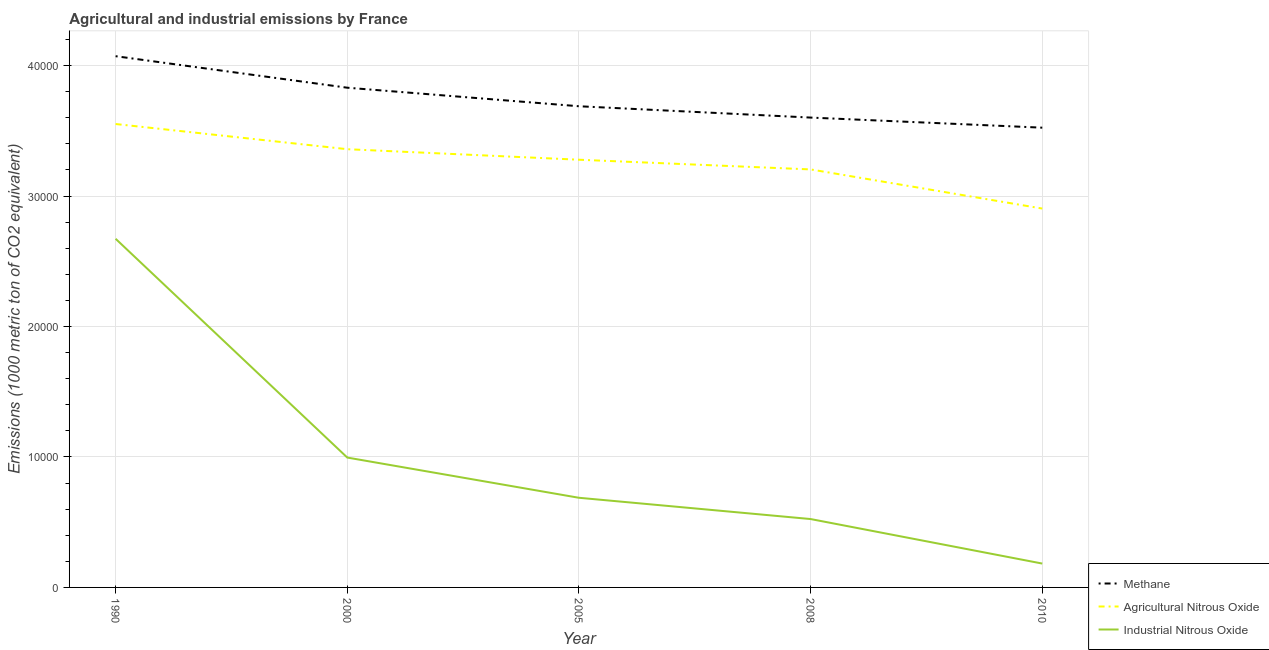What is the amount of industrial nitrous oxide emissions in 1990?
Ensure brevity in your answer.  2.67e+04. Across all years, what is the maximum amount of agricultural nitrous oxide emissions?
Provide a short and direct response. 3.55e+04. Across all years, what is the minimum amount of industrial nitrous oxide emissions?
Your answer should be very brief. 1828.8. What is the total amount of industrial nitrous oxide emissions in the graph?
Provide a succinct answer. 5.06e+04. What is the difference between the amount of methane emissions in 2000 and that in 2005?
Offer a very short reply. 1421.2. What is the difference between the amount of methane emissions in 1990 and the amount of industrial nitrous oxide emissions in 2005?
Your answer should be compact. 3.38e+04. What is the average amount of methane emissions per year?
Offer a very short reply. 3.74e+04. In the year 2008, what is the difference between the amount of methane emissions and amount of industrial nitrous oxide emissions?
Offer a very short reply. 3.08e+04. What is the ratio of the amount of agricultural nitrous oxide emissions in 2005 to that in 2008?
Give a very brief answer. 1.02. What is the difference between the highest and the second highest amount of methane emissions?
Provide a succinct answer. 2415.3. What is the difference between the highest and the lowest amount of methane emissions?
Offer a very short reply. 5479. Is it the case that in every year, the sum of the amount of methane emissions and amount of agricultural nitrous oxide emissions is greater than the amount of industrial nitrous oxide emissions?
Keep it short and to the point. Yes. Does the amount of methane emissions monotonically increase over the years?
Provide a succinct answer. No. Is the amount of agricultural nitrous oxide emissions strictly less than the amount of industrial nitrous oxide emissions over the years?
Keep it short and to the point. No. What is the difference between two consecutive major ticks on the Y-axis?
Your answer should be compact. 10000. Does the graph contain grids?
Your answer should be very brief. Yes. How many legend labels are there?
Ensure brevity in your answer.  3. How are the legend labels stacked?
Your answer should be compact. Vertical. What is the title of the graph?
Offer a very short reply. Agricultural and industrial emissions by France. Does "Social Protection and Labor" appear as one of the legend labels in the graph?
Make the answer very short. No. What is the label or title of the Y-axis?
Make the answer very short. Emissions (1000 metric ton of CO2 equivalent). What is the Emissions (1000 metric ton of CO2 equivalent) of Methane in 1990?
Your answer should be very brief. 4.07e+04. What is the Emissions (1000 metric ton of CO2 equivalent) of Agricultural Nitrous Oxide in 1990?
Keep it short and to the point. 3.55e+04. What is the Emissions (1000 metric ton of CO2 equivalent) of Industrial Nitrous Oxide in 1990?
Your answer should be compact. 2.67e+04. What is the Emissions (1000 metric ton of CO2 equivalent) of Methane in 2000?
Offer a very short reply. 3.83e+04. What is the Emissions (1000 metric ton of CO2 equivalent) in Agricultural Nitrous Oxide in 2000?
Ensure brevity in your answer.  3.36e+04. What is the Emissions (1000 metric ton of CO2 equivalent) in Industrial Nitrous Oxide in 2000?
Offer a very short reply. 9953.8. What is the Emissions (1000 metric ton of CO2 equivalent) of Methane in 2005?
Provide a short and direct response. 3.69e+04. What is the Emissions (1000 metric ton of CO2 equivalent) in Agricultural Nitrous Oxide in 2005?
Your answer should be compact. 3.28e+04. What is the Emissions (1000 metric ton of CO2 equivalent) in Industrial Nitrous Oxide in 2005?
Make the answer very short. 6871.6. What is the Emissions (1000 metric ton of CO2 equivalent) of Methane in 2008?
Your response must be concise. 3.60e+04. What is the Emissions (1000 metric ton of CO2 equivalent) of Agricultural Nitrous Oxide in 2008?
Your response must be concise. 3.20e+04. What is the Emissions (1000 metric ton of CO2 equivalent) in Industrial Nitrous Oxide in 2008?
Your answer should be compact. 5241.3. What is the Emissions (1000 metric ton of CO2 equivalent) of Methane in 2010?
Provide a succinct answer. 3.52e+04. What is the Emissions (1000 metric ton of CO2 equivalent) in Agricultural Nitrous Oxide in 2010?
Offer a very short reply. 2.90e+04. What is the Emissions (1000 metric ton of CO2 equivalent) in Industrial Nitrous Oxide in 2010?
Your answer should be very brief. 1828.8. Across all years, what is the maximum Emissions (1000 metric ton of CO2 equivalent) in Methane?
Your response must be concise. 4.07e+04. Across all years, what is the maximum Emissions (1000 metric ton of CO2 equivalent) of Agricultural Nitrous Oxide?
Give a very brief answer. 3.55e+04. Across all years, what is the maximum Emissions (1000 metric ton of CO2 equivalent) of Industrial Nitrous Oxide?
Offer a very short reply. 2.67e+04. Across all years, what is the minimum Emissions (1000 metric ton of CO2 equivalent) in Methane?
Your answer should be very brief. 3.52e+04. Across all years, what is the minimum Emissions (1000 metric ton of CO2 equivalent) in Agricultural Nitrous Oxide?
Provide a succinct answer. 2.90e+04. Across all years, what is the minimum Emissions (1000 metric ton of CO2 equivalent) in Industrial Nitrous Oxide?
Make the answer very short. 1828.8. What is the total Emissions (1000 metric ton of CO2 equivalent) of Methane in the graph?
Make the answer very short. 1.87e+05. What is the total Emissions (1000 metric ton of CO2 equivalent) in Agricultural Nitrous Oxide in the graph?
Ensure brevity in your answer.  1.63e+05. What is the total Emissions (1000 metric ton of CO2 equivalent) in Industrial Nitrous Oxide in the graph?
Your answer should be very brief. 5.06e+04. What is the difference between the Emissions (1000 metric ton of CO2 equivalent) in Methane in 1990 and that in 2000?
Offer a terse response. 2415.3. What is the difference between the Emissions (1000 metric ton of CO2 equivalent) in Agricultural Nitrous Oxide in 1990 and that in 2000?
Ensure brevity in your answer.  1930.3. What is the difference between the Emissions (1000 metric ton of CO2 equivalent) of Industrial Nitrous Oxide in 1990 and that in 2000?
Your response must be concise. 1.68e+04. What is the difference between the Emissions (1000 metric ton of CO2 equivalent) of Methane in 1990 and that in 2005?
Keep it short and to the point. 3836.5. What is the difference between the Emissions (1000 metric ton of CO2 equivalent) of Agricultural Nitrous Oxide in 1990 and that in 2005?
Give a very brief answer. 2736.8. What is the difference between the Emissions (1000 metric ton of CO2 equivalent) of Industrial Nitrous Oxide in 1990 and that in 2005?
Make the answer very short. 1.99e+04. What is the difference between the Emissions (1000 metric ton of CO2 equivalent) in Methane in 1990 and that in 2008?
Offer a terse response. 4704.7. What is the difference between the Emissions (1000 metric ton of CO2 equivalent) of Agricultural Nitrous Oxide in 1990 and that in 2008?
Provide a succinct answer. 3480.3. What is the difference between the Emissions (1000 metric ton of CO2 equivalent) of Industrial Nitrous Oxide in 1990 and that in 2008?
Provide a short and direct response. 2.15e+04. What is the difference between the Emissions (1000 metric ton of CO2 equivalent) of Methane in 1990 and that in 2010?
Your response must be concise. 5479. What is the difference between the Emissions (1000 metric ton of CO2 equivalent) in Agricultural Nitrous Oxide in 1990 and that in 2010?
Offer a terse response. 6479.5. What is the difference between the Emissions (1000 metric ton of CO2 equivalent) in Industrial Nitrous Oxide in 1990 and that in 2010?
Offer a very short reply. 2.49e+04. What is the difference between the Emissions (1000 metric ton of CO2 equivalent) in Methane in 2000 and that in 2005?
Provide a succinct answer. 1421.2. What is the difference between the Emissions (1000 metric ton of CO2 equivalent) in Agricultural Nitrous Oxide in 2000 and that in 2005?
Your answer should be compact. 806.5. What is the difference between the Emissions (1000 metric ton of CO2 equivalent) of Industrial Nitrous Oxide in 2000 and that in 2005?
Make the answer very short. 3082.2. What is the difference between the Emissions (1000 metric ton of CO2 equivalent) of Methane in 2000 and that in 2008?
Your response must be concise. 2289.4. What is the difference between the Emissions (1000 metric ton of CO2 equivalent) of Agricultural Nitrous Oxide in 2000 and that in 2008?
Ensure brevity in your answer.  1550. What is the difference between the Emissions (1000 metric ton of CO2 equivalent) of Industrial Nitrous Oxide in 2000 and that in 2008?
Make the answer very short. 4712.5. What is the difference between the Emissions (1000 metric ton of CO2 equivalent) in Methane in 2000 and that in 2010?
Provide a short and direct response. 3063.7. What is the difference between the Emissions (1000 metric ton of CO2 equivalent) of Agricultural Nitrous Oxide in 2000 and that in 2010?
Offer a very short reply. 4549.2. What is the difference between the Emissions (1000 metric ton of CO2 equivalent) in Industrial Nitrous Oxide in 2000 and that in 2010?
Your response must be concise. 8125. What is the difference between the Emissions (1000 metric ton of CO2 equivalent) of Methane in 2005 and that in 2008?
Make the answer very short. 868.2. What is the difference between the Emissions (1000 metric ton of CO2 equivalent) in Agricultural Nitrous Oxide in 2005 and that in 2008?
Your answer should be very brief. 743.5. What is the difference between the Emissions (1000 metric ton of CO2 equivalent) of Industrial Nitrous Oxide in 2005 and that in 2008?
Make the answer very short. 1630.3. What is the difference between the Emissions (1000 metric ton of CO2 equivalent) in Methane in 2005 and that in 2010?
Offer a terse response. 1642.5. What is the difference between the Emissions (1000 metric ton of CO2 equivalent) of Agricultural Nitrous Oxide in 2005 and that in 2010?
Make the answer very short. 3742.7. What is the difference between the Emissions (1000 metric ton of CO2 equivalent) of Industrial Nitrous Oxide in 2005 and that in 2010?
Give a very brief answer. 5042.8. What is the difference between the Emissions (1000 metric ton of CO2 equivalent) of Methane in 2008 and that in 2010?
Offer a very short reply. 774.3. What is the difference between the Emissions (1000 metric ton of CO2 equivalent) of Agricultural Nitrous Oxide in 2008 and that in 2010?
Your response must be concise. 2999.2. What is the difference between the Emissions (1000 metric ton of CO2 equivalent) of Industrial Nitrous Oxide in 2008 and that in 2010?
Provide a succinct answer. 3412.5. What is the difference between the Emissions (1000 metric ton of CO2 equivalent) of Methane in 1990 and the Emissions (1000 metric ton of CO2 equivalent) of Agricultural Nitrous Oxide in 2000?
Your answer should be very brief. 7128.7. What is the difference between the Emissions (1000 metric ton of CO2 equivalent) in Methane in 1990 and the Emissions (1000 metric ton of CO2 equivalent) in Industrial Nitrous Oxide in 2000?
Make the answer very short. 3.08e+04. What is the difference between the Emissions (1000 metric ton of CO2 equivalent) in Agricultural Nitrous Oxide in 1990 and the Emissions (1000 metric ton of CO2 equivalent) in Industrial Nitrous Oxide in 2000?
Your answer should be compact. 2.56e+04. What is the difference between the Emissions (1000 metric ton of CO2 equivalent) of Methane in 1990 and the Emissions (1000 metric ton of CO2 equivalent) of Agricultural Nitrous Oxide in 2005?
Keep it short and to the point. 7935.2. What is the difference between the Emissions (1000 metric ton of CO2 equivalent) of Methane in 1990 and the Emissions (1000 metric ton of CO2 equivalent) of Industrial Nitrous Oxide in 2005?
Ensure brevity in your answer.  3.38e+04. What is the difference between the Emissions (1000 metric ton of CO2 equivalent) of Agricultural Nitrous Oxide in 1990 and the Emissions (1000 metric ton of CO2 equivalent) of Industrial Nitrous Oxide in 2005?
Offer a terse response. 2.86e+04. What is the difference between the Emissions (1000 metric ton of CO2 equivalent) of Methane in 1990 and the Emissions (1000 metric ton of CO2 equivalent) of Agricultural Nitrous Oxide in 2008?
Your response must be concise. 8678.7. What is the difference between the Emissions (1000 metric ton of CO2 equivalent) of Methane in 1990 and the Emissions (1000 metric ton of CO2 equivalent) of Industrial Nitrous Oxide in 2008?
Give a very brief answer. 3.55e+04. What is the difference between the Emissions (1000 metric ton of CO2 equivalent) of Agricultural Nitrous Oxide in 1990 and the Emissions (1000 metric ton of CO2 equivalent) of Industrial Nitrous Oxide in 2008?
Your response must be concise. 3.03e+04. What is the difference between the Emissions (1000 metric ton of CO2 equivalent) of Methane in 1990 and the Emissions (1000 metric ton of CO2 equivalent) of Agricultural Nitrous Oxide in 2010?
Your response must be concise. 1.17e+04. What is the difference between the Emissions (1000 metric ton of CO2 equivalent) of Methane in 1990 and the Emissions (1000 metric ton of CO2 equivalent) of Industrial Nitrous Oxide in 2010?
Ensure brevity in your answer.  3.89e+04. What is the difference between the Emissions (1000 metric ton of CO2 equivalent) in Agricultural Nitrous Oxide in 1990 and the Emissions (1000 metric ton of CO2 equivalent) in Industrial Nitrous Oxide in 2010?
Make the answer very short. 3.37e+04. What is the difference between the Emissions (1000 metric ton of CO2 equivalent) of Methane in 2000 and the Emissions (1000 metric ton of CO2 equivalent) of Agricultural Nitrous Oxide in 2005?
Keep it short and to the point. 5519.9. What is the difference between the Emissions (1000 metric ton of CO2 equivalent) of Methane in 2000 and the Emissions (1000 metric ton of CO2 equivalent) of Industrial Nitrous Oxide in 2005?
Keep it short and to the point. 3.14e+04. What is the difference between the Emissions (1000 metric ton of CO2 equivalent) of Agricultural Nitrous Oxide in 2000 and the Emissions (1000 metric ton of CO2 equivalent) of Industrial Nitrous Oxide in 2005?
Your answer should be very brief. 2.67e+04. What is the difference between the Emissions (1000 metric ton of CO2 equivalent) in Methane in 2000 and the Emissions (1000 metric ton of CO2 equivalent) in Agricultural Nitrous Oxide in 2008?
Provide a succinct answer. 6263.4. What is the difference between the Emissions (1000 metric ton of CO2 equivalent) of Methane in 2000 and the Emissions (1000 metric ton of CO2 equivalent) of Industrial Nitrous Oxide in 2008?
Provide a succinct answer. 3.31e+04. What is the difference between the Emissions (1000 metric ton of CO2 equivalent) in Agricultural Nitrous Oxide in 2000 and the Emissions (1000 metric ton of CO2 equivalent) in Industrial Nitrous Oxide in 2008?
Your response must be concise. 2.83e+04. What is the difference between the Emissions (1000 metric ton of CO2 equivalent) of Methane in 2000 and the Emissions (1000 metric ton of CO2 equivalent) of Agricultural Nitrous Oxide in 2010?
Offer a terse response. 9262.6. What is the difference between the Emissions (1000 metric ton of CO2 equivalent) in Methane in 2000 and the Emissions (1000 metric ton of CO2 equivalent) in Industrial Nitrous Oxide in 2010?
Keep it short and to the point. 3.65e+04. What is the difference between the Emissions (1000 metric ton of CO2 equivalent) of Agricultural Nitrous Oxide in 2000 and the Emissions (1000 metric ton of CO2 equivalent) of Industrial Nitrous Oxide in 2010?
Offer a terse response. 3.18e+04. What is the difference between the Emissions (1000 metric ton of CO2 equivalent) in Methane in 2005 and the Emissions (1000 metric ton of CO2 equivalent) in Agricultural Nitrous Oxide in 2008?
Offer a very short reply. 4842.2. What is the difference between the Emissions (1000 metric ton of CO2 equivalent) in Methane in 2005 and the Emissions (1000 metric ton of CO2 equivalent) in Industrial Nitrous Oxide in 2008?
Give a very brief answer. 3.16e+04. What is the difference between the Emissions (1000 metric ton of CO2 equivalent) of Agricultural Nitrous Oxide in 2005 and the Emissions (1000 metric ton of CO2 equivalent) of Industrial Nitrous Oxide in 2008?
Keep it short and to the point. 2.75e+04. What is the difference between the Emissions (1000 metric ton of CO2 equivalent) of Methane in 2005 and the Emissions (1000 metric ton of CO2 equivalent) of Agricultural Nitrous Oxide in 2010?
Provide a succinct answer. 7841.4. What is the difference between the Emissions (1000 metric ton of CO2 equivalent) of Methane in 2005 and the Emissions (1000 metric ton of CO2 equivalent) of Industrial Nitrous Oxide in 2010?
Your answer should be compact. 3.51e+04. What is the difference between the Emissions (1000 metric ton of CO2 equivalent) in Agricultural Nitrous Oxide in 2005 and the Emissions (1000 metric ton of CO2 equivalent) in Industrial Nitrous Oxide in 2010?
Offer a terse response. 3.10e+04. What is the difference between the Emissions (1000 metric ton of CO2 equivalent) of Methane in 2008 and the Emissions (1000 metric ton of CO2 equivalent) of Agricultural Nitrous Oxide in 2010?
Give a very brief answer. 6973.2. What is the difference between the Emissions (1000 metric ton of CO2 equivalent) in Methane in 2008 and the Emissions (1000 metric ton of CO2 equivalent) in Industrial Nitrous Oxide in 2010?
Offer a terse response. 3.42e+04. What is the difference between the Emissions (1000 metric ton of CO2 equivalent) in Agricultural Nitrous Oxide in 2008 and the Emissions (1000 metric ton of CO2 equivalent) in Industrial Nitrous Oxide in 2010?
Keep it short and to the point. 3.02e+04. What is the average Emissions (1000 metric ton of CO2 equivalent) of Methane per year?
Provide a succinct answer. 3.74e+04. What is the average Emissions (1000 metric ton of CO2 equivalent) in Agricultural Nitrous Oxide per year?
Your response must be concise. 3.26e+04. What is the average Emissions (1000 metric ton of CO2 equivalent) of Industrial Nitrous Oxide per year?
Make the answer very short. 1.01e+04. In the year 1990, what is the difference between the Emissions (1000 metric ton of CO2 equivalent) of Methane and Emissions (1000 metric ton of CO2 equivalent) of Agricultural Nitrous Oxide?
Your answer should be compact. 5198.4. In the year 1990, what is the difference between the Emissions (1000 metric ton of CO2 equivalent) of Methane and Emissions (1000 metric ton of CO2 equivalent) of Industrial Nitrous Oxide?
Keep it short and to the point. 1.40e+04. In the year 1990, what is the difference between the Emissions (1000 metric ton of CO2 equivalent) of Agricultural Nitrous Oxide and Emissions (1000 metric ton of CO2 equivalent) of Industrial Nitrous Oxide?
Your answer should be compact. 8797.6. In the year 2000, what is the difference between the Emissions (1000 metric ton of CO2 equivalent) of Methane and Emissions (1000 metric ton of CO2 equivalent) of Agricultural Nitrous Oxide?
Your response must be concise. 4713.4. In the year 2000, what is the difference between the Emissions (1000 metric ton of CO2 equivalent) of Methane and Emissions (1000 metric ton of CO2 equivalent) of Industrial Nitrous Oxide?
Offer a very short reply. 2.83e+04. In the year 2000, what is the difference between the Emissions (1000 metric ton of CO2 equivalent) in Agricultural Nitrous Oxide and Emissions (1000 metric ton of CO2 equivalent) in Industrial Nitrous Oxide?
Provide a short and direct response. 2.36e+04. In the year 2005, what is the difference between the Emissions (1000 metric ton of CO2 equivalent) of Methane and Emissions (1000 metric ton of CO2 equivalent) of Agricultural Nitrous Oxide?
Your answer should be compact. 4098.7. In the year 2005, what is the difference between the Emissions (1000 metric ton of CO2 equivalent) of Methane and Emissions (1000 metric ton of CO2 equivalent) of Industrial Nitrous Oxide?
Ensure brevity in your answer.  3.00e+04. In the year 2005, what is the difference between the Emissions (1000 metric ton of CO2 equivalent) in Agricultural Nitrous Oxide and Emissions (1000 metric ton of CO2 equivalent) in Industrial Nitrous Oxide?
Keep it short and to the point. 2.59e+04. In the year 2008, what is the difference between the Emissions (1000 metric ton of CO2 equivalent) of Methane and Emissions (1000 metric ton of CO2 equivalent) of Agricultural Nitrous Oxide?
Provide a succinct answer. 3974. In the year 2008, what is the difference between the Emissions (1000 metric ton of CO2 equivalent) in Methane and Emissions (1000 metric ton of CO2 equivalent) in Industrial Nitrous Oxide?
Provide a short and direct response. 3.08e+04. In the year 2008, what is the difference between the Emissions (1000 metric ton of CO2 equivalent) of Agricultural Nitrous Oxide and Emissions (1000 metric ton of CO2 equivalent) of Industrial Nitrous Oxide?
Provide a short and direct response. 2.68e+04. In the year 2010, what is the difference between the Emissions (1000 metric ton of CO2 equivalent) in Methane and Emissions (1000 metric ton of CO2 equivalent) in Agricultural Nitrous Oxide?
Offer a very short reply. 6198.9. In the year 2010, what is the difference between the Emissions (1000 metric ton of CO2 equivalent) in Methane and Emissions (1000 metric ton of CO2 equivalent) in Industrial Nitrous Oxide?
Your answer should be compact. 3.34e+04. In the year 2010, what is the difference between the Emissions (1000 metric ton of CO2 equivalent) in Agricultural Nitrous Oxide and Emissions (1000 metric ton of CO2 equivalent) in Industrial Nitrous Oxide?
Ensure brevity in your answer.  2.72e+04. What is the ratio of the Emissions (1000 metric ton of CO2 equivalent) of Methane in 1990 to that in 2000?
Provide a succinct answer. 1.06. What is the ratio of the Emissions (1000 metric ton of CO2 equivalent) of Agricultural Nitrous Oxide in 1990 to that in 2000?
Your response must be concise. 1.06. What is the ratio of the Emissions (1000 metric ton of CO2 equivalent) of Industrial Nitrous Oxide in 1990 to that in 2000?
Offer a terse response. 2.68. What is the ratio of the Emissions (1000 metric ton of CO2 equivalent) of Methane in 1990 to that in 2005?
Offer a very short reply. 1.1. What is the ratio of the Emissions (1000 metric ton of CO2 equivalent) in Agricultural Nitrous Oxide in 1990 to that in 2005?
Give a very brief answer. 1.08. What is the ratio of the Emissions (1000 metric ton of CO2 equivalent) of Industrial Nitrous Oxide in 1990 to that in 2005?
Provide a succinct answer. 3.89. What is the ratio of the Emissions (1000 metric ton of CO2 equivalent) in Methane in 1990 to that in 2008?
Offer a terse response. 1.13. What is the ratio of the Emissions (1000 metric ton of CO2 equivalent) of Agricultural Nitrous Oxide in 1990 to that in 2008?
Provide a short and direct response. 1.11. What is the ratio of the Emissions (1000 metric ton of CO2 equivalent) of Industrial Nitrous Oxide in 1990 to that in 2008?
Your answer should be compact. 5.1. What is the ratio of the Emissions (1000 metric ton of CO2 equivalent) of Methane in 1990 to that in 2010?
Your answer should be compact. 1.16. What is the ratio of the Emissions (1000 metric ton of CO2 equivalent) of Agricultural Nitrous Oxide in 1990 to that in 2010?
Keep it short and to the point. 1.22. What is the ratio of the Emissions (1000 metric ton of CO2 equivalent) of Industrial Nitrous Oxide in 1990 to that in 2010?
Keep it short and to the point. 14.61. What is the ratio of the Emissions (1000 metric ton of CO2 equivalent) of Methane in 2000 to that in 2005?
Your answer should be compact. 1.04. What is the ratio of the Emissions (1000 metric ton of CO2 equivalent) in Agricultural Nitrous Oxide in 2000 to that in 2005?
Ensure brevity in your answer.  1.02. What is the ratio of the Emissions (1000 metric ton of CO2 equivalent) in Industrial Nitrous Oxide in 2000 to that in 2005?
Offer a terse response. 1.45. What is the ratio of the Emissions (1000 metric ton of CO2 equivalent) in Methane in 2000 to that in 2008?
Ensure brevity in your answer.  1.06. What is the ratio of the Emissions (1000 metric ton of CO2 equivalent) in Agricultural Nitrous Oxide in 2000 to that in 2008?
Provide a succinct answer. 1.05. What is the ratio of the Emissions (1000 metric ton of CO2 equivalent) in Industrial Nitrous Oxide in 2000 to that in 2008?
Provide a succinct answer. 1.9. What is the ratio of the Emissions (1000 metric ton of CO2 equivalent) of Methane in 2000 to that in 2010?
Your response must be concise. 1.09. What is the ratio of the Emissions (1000 metric ton of CO2 equivalent) of Agricultural Nitrous Oxide in 2000 to that in 2010?
Offer a very short reply. 1.16. What is the ratio of the Emissions (1000 metric ton of CO2 equivalent) in Industrial Nitrous Oxide in 2000 to that in 2010?
Your response must be concise. 5.44. What is the ratio of the Emissions (1000 metric ton of CO2 equivalent) of Methane in 2005 to that in 2008?
Provide a succinct answer. 1.02. What is the ratio of the Emissions (1000 metric ton of CO2 equivalent) in Agricultural Nitrous Oxide in 2005 to that in 2008?
Your answer should be compact. 1.02. What is the ratio of the Emissions (1000 metric ton of CO2 equivalent) in Industrial Nitrous Oxide in 2005 to that in 2008?
Give a very brief answer. 1.31. What is the ratio of the Emissions (1000 metric ton of CO2 equivalent) of Methane in 2005 to that in 2010?
Keep it short and to the point. 1.05. What is the ratio of the Emissions (1000 metric ton of CO2 equivalent) in Agricultural Nitrous Oxide in 2005 to that in 2010?
Offer a terse response. 1.13. What is the ratio of the Emissions (1000 metric ton of CO2 equivalent) in Industrial Nitrous Oxide in 2005 to that in 2010?
Make the answer very short. 3.76. What is the ratio of the Emissions (1000 metric ton of CO2 equivalent) in Methane in 2008 to that in 2010?
Offer a terse response. 1.02. What is the ratio of the Emissions (1000 metric ton of CO2 equivalent) in Agricultural Nitrous Oxide in 2008 to that in 2010?
Make the answer very short. 1.1. What is the ratio of the Emissions (1000 metric ton of CO2 equivalent) of Industrial Nitrous Oxide in 2008 to that in 2010?
Provide a succinct answer. 2.87. What is the difference between the highest and the second highest Emissions (1000 metric ton of CO2 equivalent) in Methane?
Provide a succinct answer. 2415.3. What is the difference between the highest and the second highest Emissions (1000 metric ton of CO2 equivalent) of Agricultural Nitrous Oxide?
Offer a very short reply. 1930.3. What is the difference between the highest and the second highest Emissions (1000 metric ton of CO2 equivalent) of Industrial Nitrous Oxide?
Your answer should be compact. 1.68e+04. What is the difference between the highest and the lowest Emissions (1000 metric ton of CO2 equivalent) of Methane?
Ensure brevity in your answer.  5479. What is the difference between the highest and the lowest Emissions (1000 metric ton of CO2 equivalent) in Agricultural Nitrous Oxide?
Make the answer very short. 6479.5. What is the difference between the highest and the lowest Emissions (1000 metric ton of CO2 equivalent) of Industrial Nitrous Oxide?
Make the answer very short. 2.49e+04. 